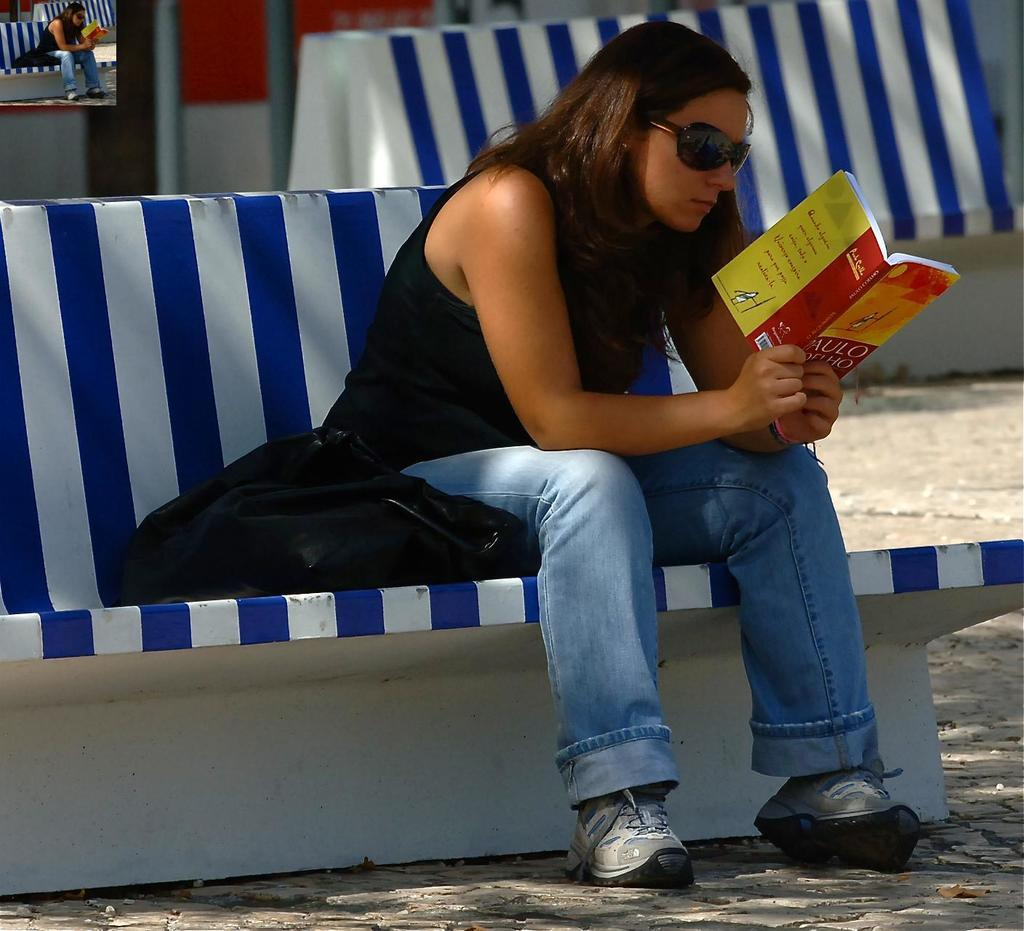Provide a one-sentence caption for the provided image. A girl sitting on a blue and white bench hold a book by Paulo in her hand. 